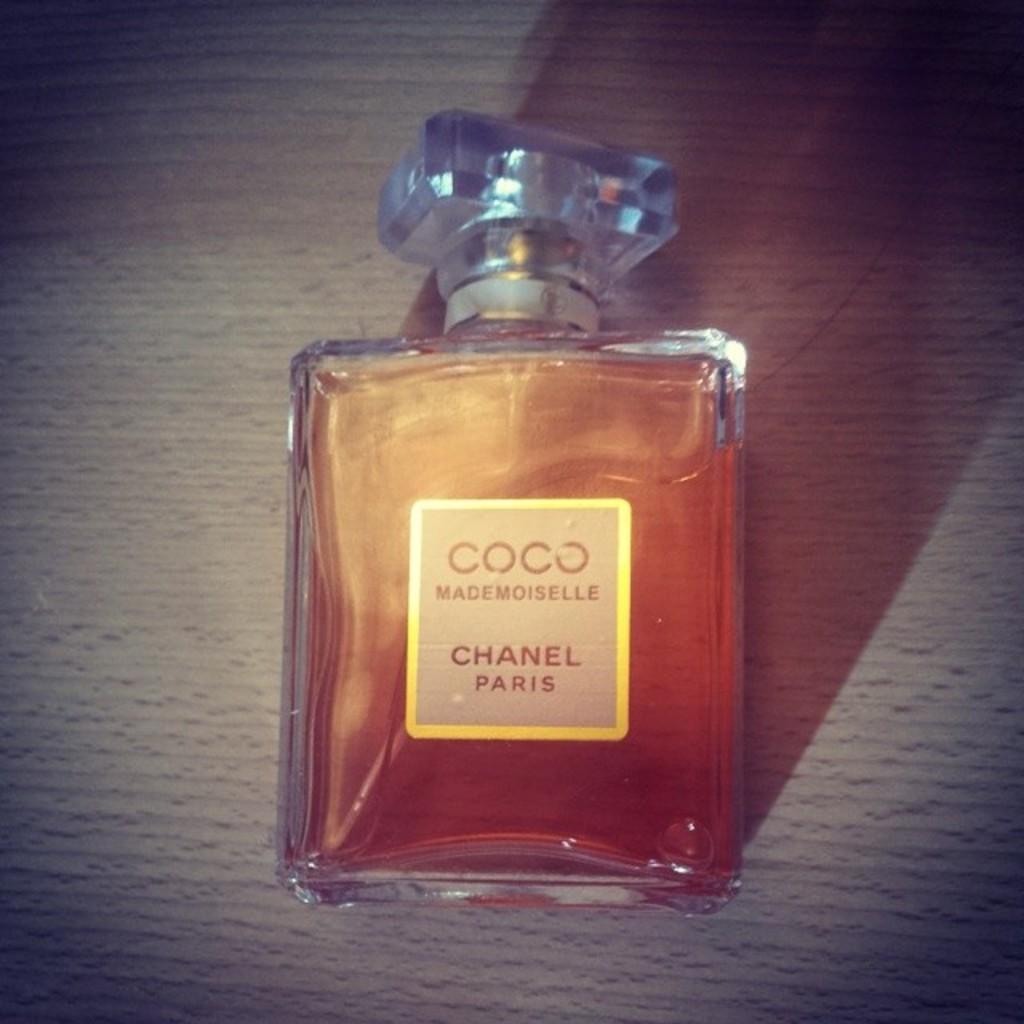What brand is this?
Your response must be concise. Chanel. 